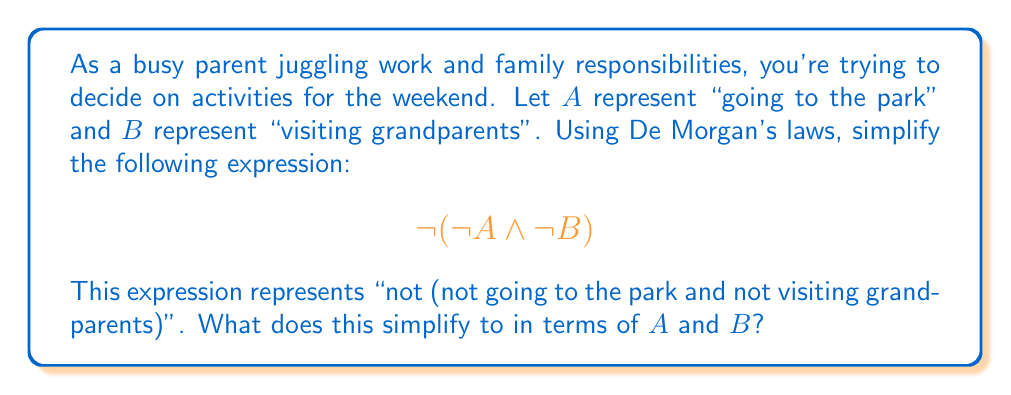Can you solve this math problem? Let's apply De Morgan's laws step-by-step:

1) The given expression is $\lnot(\lnot A \land \lnot B)$

2) De Morgan's law states that:
   $\lnot(P \land Q) = \lnot P \lor \lnot Q$

3) In our case, $P = \lnot A$ and $Q = \lnot B$

4) Applying De Morgan's law:
   $\lnot(\lnot A \land \lnot B) = \lnot(\lnot A) \lor \lnot(\lnot B)$

5) The double negation rule states that $\lnot(\lnot X) = X$

6) Applying this rule to both terms:
   $\lnot(\lnot A) \lor \lnot(\lnot B) = A \lor B$

Therefore, $\lnot(\lnot A \land \lnot B)$ simplifies to $A \lor B$.

In the context of family decision-making, this means that "not (not going to the park and not visiting grandparents)" is equivalent to "going to the park or visiting grandparents". This simplification can help in clearly understanding and communicating family plans.
Answer: $A \lor B$ 